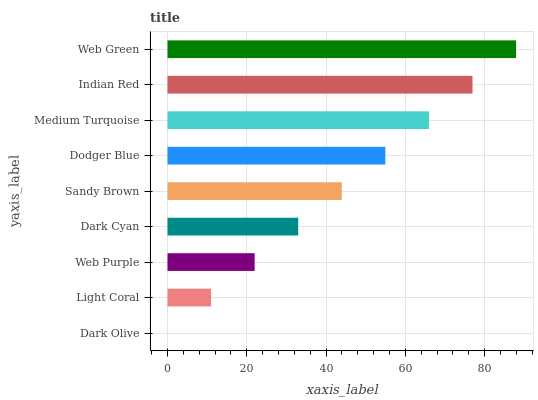Is Dark Olive the minimum?
Answer yes or no. Yes. Is Web Green the maximum?
Answer yes or no. Yes. Is Light Coral the minimum?
Answer yes or no. No. Is Light Coral the maximum?
Answer yes or no. No. Is Light Coral greater than Dark Olive?
Answer yes or no. Yes. Is Dark Olive less than Light Coral?
Answer yes or no. Yes. Is Dark Olive greater than Light Coral?
Answer yes or no. No. Is Light Coral less than Dark Olive?
Answer yes or no. No. Is Sandy Brown the high median?
Answer yes or no. Yes. Is Sandy Brown the low median?
Answer yes or no. Yes. Is Dark Cyan the high median?
Answer yes or no. No. Is Dodger Blue the low median?
Answer yes or no. No. 